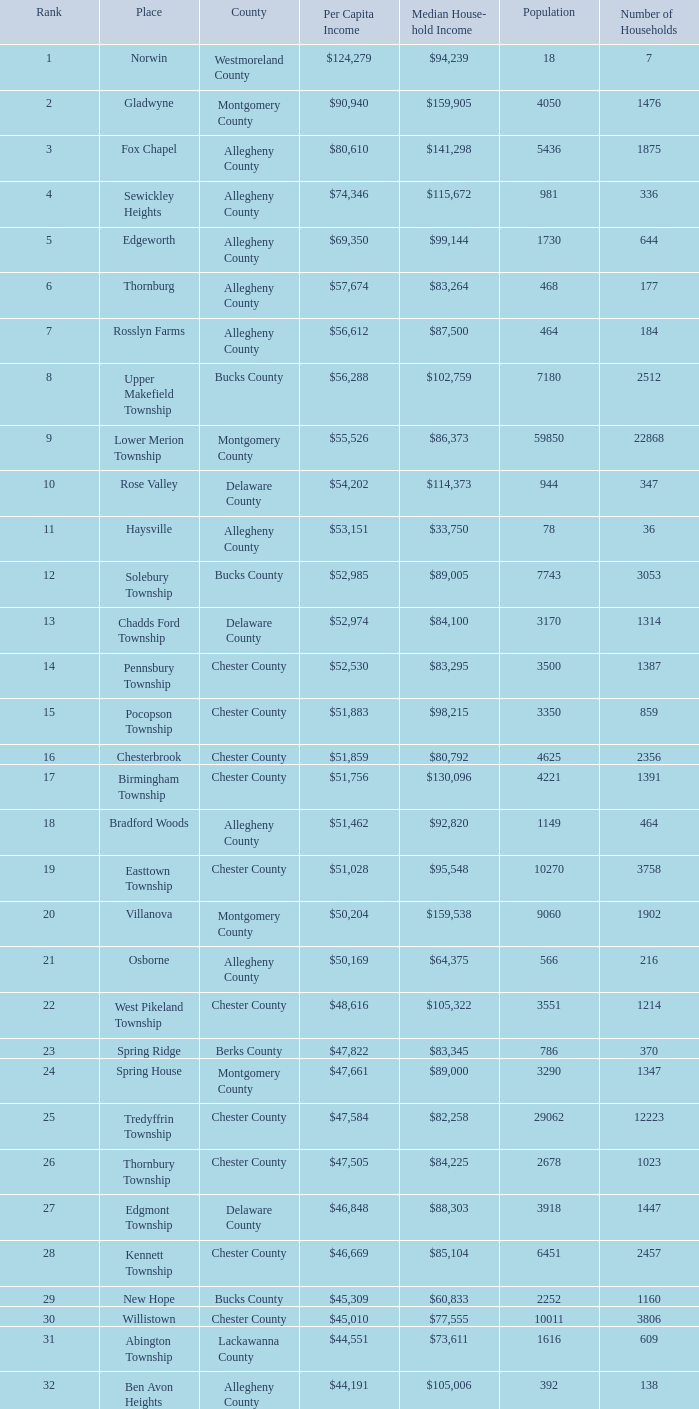What is the median household income for Woodside? $121,151. 